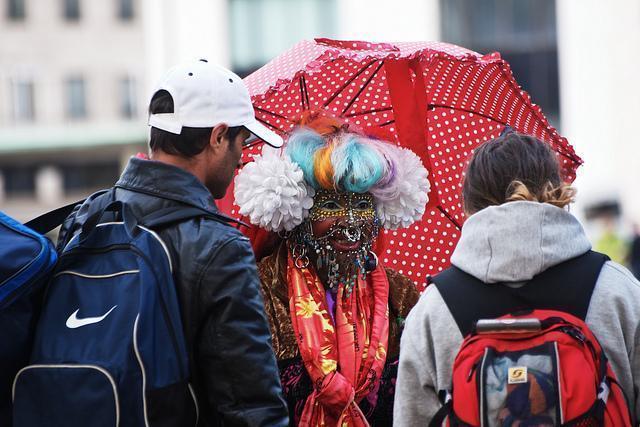What does the woman have all over her face?
Select the accurate answer and provide explanation: 'Answer: answer
Rationale: rationale.'
Options: Hair, piercings, stickers, food. Answer: piercings.
Rationale: The woman has her faces covered with jewelries. 